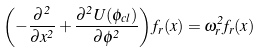Convert formula to latex. <formula><loc_0><loc_0><loc_500><loc_500>\left ( - \frac { \partial ^ { 2 } } { \partial x ^ { 2 } } + \frac { \partial ^ { 2 } U ( \phi _ { c l } ) } { \partial \phi ^ { 2 } } \right ) f _ { r } ( x ) = \omega _ { r } ^ { 2 } f _ { r } ( x )</formula> 